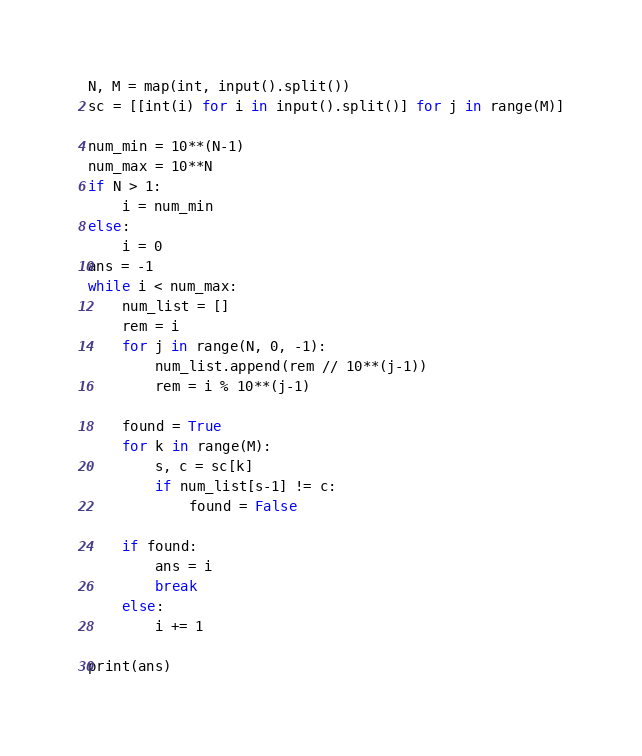Convert code to text. <code><loc_0><loc_0><loc_500><loc_500><_Python_>N, M = map(int, input().split())
sc = [[int(i) for i in input().split()] for j in range(M)]

num_min = 10**(N-1)
num_max = 10**N
if N > 1:
    i = num_min
else:
    i = 0
ans = -1
while i < num_max:
    num_list = []
    rem = i
    for j in range(N, 0, -1):
        num_list.append(rem // 10**(j-1))
        rem = i % 10**(j-1)
    
    found = True
    for k in range(M):
        s, c = sc[k]
        if num_list[s-1] != c:
            found = False
    
    if found:
        ans = i
        break
    else:
        i += 1

print(ans)</code> 